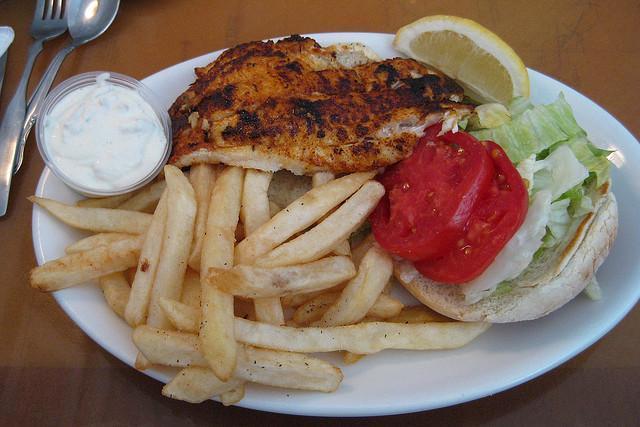How many oranges are there?
Give a very brief answer. 1. How many sandwiches can be seen?
Give a very brief answer. 2. 